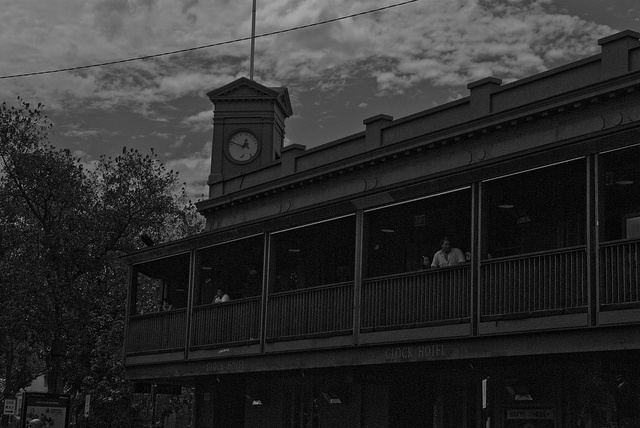Describe the objects in this image and their specific colors. I can see clock in black and gray tones, people in black and gray tones, people in black and gray tones, people in black and gray tones, and people in black and gray tones in this image. 